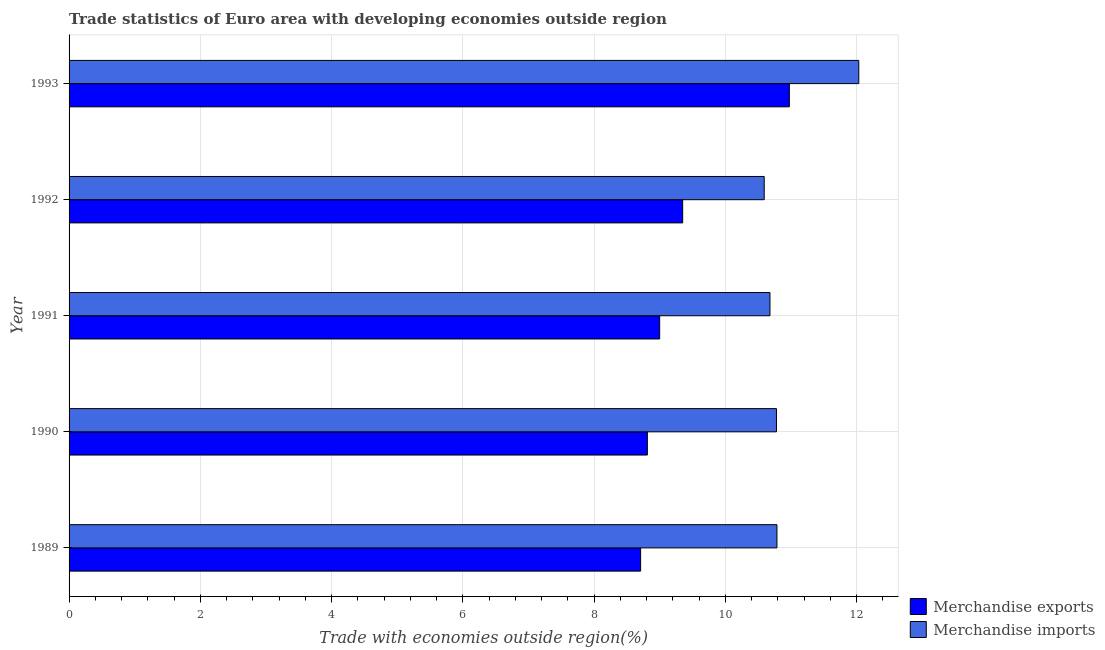How many different coloured bars are there?
Give a very brief answer. 2. Are the number of bars per tick equal to the number of legend labels?
Your answer should be very brief. Yes. Are the number of bars on each tick of the Y-axis equal?
Offer a terse response. Yes. How many bars are there on the 1st tick from the top?
Ensure brevity in your answer.  2. What is the label of the 4th group of bars from the top?
Offer a very short reply. 1990. In how many cases, is the number of bars for a given year not equal to the number of legend labels?
Your answer should be very brief. 0. What is the merchandise imports in 1992?
Offer a very short reply. 10.59. Across all years, what is the maximum merchandise exports?
Make the answer very short. 10.98. Across all years, what is the minimum merchandise imports?
Give a very brief answer. 10.59. In which year was the merchandise imports maximum?
Give a very brief answer. 1993. What is the total merchandise exports in the graph?
Your answer should be very brief. 46.85. What is the difference between the merchandise exports in 1989 and that in 1992?
Offer a terse response. -0.64. What is the difference between the merchandise imports in 1992 and the merchandise exports in 1989?
Give a very brief answer. 1.88. What is the average merchandise imports per year?
Keep it short and to the point. 10.97. In the year 1990, what is the difference between the merchandise imports and merchandise exports?
Ensure brevity in your answer.  1.97. In how many years, is the merchandise exports greater than 8.4 %?
Make the answer very short. 5. What is the ratio of the merchandise exports in 1991 to that in 1993?
Offer a very short reply. 0.82. Is the merchandise exports in 1990 less than that in 1993?
Your answer should be compact. Yes. What is the difference between the highest and the second highest merchandise exports?
Your answer should be very brief. 1.63. What is the difference between the highest and the lowest merchandise exports?
Ensure brevity in your answer.  2.27. In how many years, is the merchandise imports greater than the average merchandise imports taken over all years?
Ensure brevity in your answer.  1. Is the sum of the merchandise imports in 1991 and 1992 greater than the maximum merchandise exports across all years?
Your answer should be very brief. Yes. Are all the bars in the graph horizontal?
Your answer should be compact. Yes. How many years are there in the graph?
Make the answer very short. 5. Are the values on the major ticks of X-axis written in scientific E-notation?
Ensure brevity in your answer.  No. Does the graph contain any zero values?
Make the answer very short. No. Does the graph contain grids?
Your answer should be very brief. Yes. How many legend labels are there?
Ensure brevity in your answer.  2. What is the title of the graph?
Give a very brief answer. Trade statistics of Euro area with developing economies outside region. What is the label or title of the X-axis?
Offer a terse response. Trade with economies outside region(%). What is the Trade with economies outside region(%) in Merchandise exports in 1989?
Make the answer very short. 8.71. What is the Trade with economies outside region(%) of Merchandise imports in 1989?
Keep it short and to the point. 10.79. What is the Trade with economies outside region(%) of Merchandise exports in 1990?
Your answer should be compact. 8.81. What is the Trade with economies outside region(%) in Merchandise imports in 1990?
Offer a very short reply. 10.78. What is the Trade with economies outside region(%) in Merchandise exports in 1991?
Offer a very short reply. 9. What is the Trade with economies outside region(%) in Merchandise imports in 1991?
Make the answer very short. 10.68. What is the Trade with economies outside region(%) of Merchandise exports in 1992?
Make the answer very short. 9.35. What is the Trade with economies outside region(%) of Merchandise imports in 1992?
Give a very brief answer. 10.59. What is the Trade with economies outside region(%) in Merchandise exports in 1993?
Give a very brief answer. 10.98. What is the Trade with economies outside region(%) in Merchandise imports in 1993?
Your response must be concise. 12.03. Across all years, what is the maximum Trade with economies outside region(%) in Merchandise exports?
Provide a short and direct response. 10.98. Across all years, what is the maximum Trade with economies outside region(%) in Merchandise imports?
Offer a terse response. 12.03. Across all years, what is the minimum Trade with economies outside region(%) of Merchandise exports?
Your answer should be very brief. 8.71. Across all years, what is the minimum Trade with economies outside region(%) in Merchandise imports?
Provide a short and direct response. 10.59. What is the total Trade with economies outside region(%) of Merchandise exports in the graph?
Your answer should be compact. 46.85. What is the total Trade with economies outside region(%) in Merchandise imports in the graph?
Your answer should be compact. 54.88. What is the difference between the Trade with economies outside region(%) in Merchandise exports in 1989 and that in 1990?
Ensure brevity in your answer.  -0.1. What is the difference between the Trade with economies outside region(%) in Merchandise imports in 1989 and that in 1990?
Ensure brevity in your answer.  0.01. What is the difference between the Trade with economies outside region(%) of Merchandise exports in 1989 and that in 1991?
Give a very brief answer. -0.29. What is the difference between the Trade with economies outside region(%) in Merchandise imports in 1989 and that in 1991?
Ensure brevity in your answer.  0.11. What is the difference between the Trade with economies outside region(%) of Merchandise exports in 1989 and that in 1992?
Your answer should be compact. -0.64. What is the difference between the Trade with economies outside region(%) of Merchandise imports in 1989 and that in 1992?
Give a very brief answer. 0.19. What is the difference between the Trade with economies outside region(%) of Merchandise exports in 1989 and that in 1993?
Offer a very short reply. -2.27. What is the difference between the Trade with economies outside region(%) in Merchandise imports in 1989 and that in 1993?
Your answer should be compact. -1.25. What is the difference between the Trade with economies outside region(%) of Merchandise exports in 1990 and that in 1991?
Your response must be concise. -0.19. What is the difference between the Trade with economies outside region(%) of Merchandise imports in 1990 and that in 1991?
Provide a succinct answer. 0.1. What is the difference between the Trade with economies outside region(%) in Merchandise exports in 1990 and that in 1992?
Offer a terse response. -0.54. What is the difference between the Trade with economies outside region(%) of Merchandise imports in 1990 and that in 1992?
Your answer should be very brief. 0.19. What is the difference between the Trade with economies outside region(%) in Merchandise exports in 1990 and that in 1993?
Offer a very short reply. -2.16. What is the difference between the Trade with economies outside region(%) of Merchandise imports in 1990 and that in 1993?
Your answer should be compact. -1.25. What is the difference between the Trade with economies outside region(%) of Merchandise exports in 1991 and that in 1992?
Give a very brief answer. -0.35. What is the difference between the Trade with economies outside region(%) of Merchandise imports in 1991 and that in 1992?
Make the answer very short. 0.09. What is the difference between the Trade with economies outside region(%) of Merchandise exports in 1991 and that in 1993?
Give a very brief answer. -1.98. What is the difference between the Trade with economies outside region(%) of Merchandise imports in 1991 and that in 1993?
Make the answer very short. -1.35. What is the difference between the Trade with economies outside region(%) in Merchandise exports in 1992 and that in 1993?
Provide a succinct answer. -1.63. What is the difference between the Trade with economies outside region(%) in Merchandise imports in 1992 and that in 1993?
Make the answer very short. -1.44. What is the difference between the Trade with economies outside region(%) of Merchandise exports in 1989 and the Trade with economies outside region(%) of Merchandise imports in 1990?
Your answer should be very brief. -2.07. What is the difference between the Trade with economies outside region(%) in Merchandise exports in 1989 and the Trade with economies outside region(%) in Merchandise imports in 1991?
Ensure brevity in your answer.  -1.97. What is the difference between the Trade with economies outside region(%) of Merchandise exports in 1989 and the Trade with economies outside region(%) of Merchandise imports in 1992?
Provide a succinct answer. -1.88. What is the difference between the Trade with economies outside region(%) in Merchandise exports in 1989 and the Trade with economies outside region(%) in Merchandise imports in 1993?
Provide a succinct answer. -3.32. What is the difference between the Trade with economies outside region(%) in Merchandise exports in 1990 and the Trade with economies outside region(%) in Merchandise imports in 1991?
Provide a short and direct response. -1.87. What is the difference between the Trade with economies outside region(%) of Merchandise exports in 1990 and the Trade with economies outside region(%) of Merchandise imports in 1992?
Your answer should be very brief. -1.78. What is the difference between the Trade with economies outside region(%) of Merchandise exports in 1990 and the Trade with economies outside region(%) of Merchandise imports in 1993?
Your response must be concise. -3.22. What is the difference between the Trade with economies outside region(%) in Merchandise exports in 1991 and the Trade with economies outside region(%) in Merchandise imports in 1992?
Your response must be concise. -1.59. What is the difference between the Trade with economies outside region(%) of Merchandise exports in 1991 and the Trade with economies outside region(%) of Merchandise imports in 1993?
Your answer should be very brief. -3.03. What is the difference between the Trade with economies outside region(%) of Merchandise exports in 1992 and the Trade with economies outside region(%) of Merchandise imports in 1993?
Your answer should be very brief. -2.68. What is the average Trade with economies outside region(%) in Merchandise exports per year?
Offer a very short reply. 9.37. What is the average Trade with economies outside region(%) of Merchandise imports per year?
Give a very brief answer. 10.98. In the year 1989, what is the difference between the Trade with economies outside region(%) of Merchandise exports and Trade with economies outside region(%) of Merchandise imports?
Keep it short and to the point. -2.08. In the year 1990, what is the difference between the Trade with economies outside region(%) in Merchandise exports and Trade with economies outside region(%) in Merchandise imports?
Your response must be concise. -1.97. In the year 1991, what is the difference between the Trade with economies outside region(%) in Merchandise exports and Trade with economies outside region(%) in Merchandise imports?
Your response must be concise. -1.68. In the year 1992, what is the difference between the Trade with economies outside region(%) of Merchandise exports and Trade with economies outside region(%) of Merchandise imports?
Offer a terse response. -1.24. In the year 1993, what is the difference between the Trade with economies outside region(%) in Merchandise exports and Trade with economies outside region(%) in Merchandise imports?
Make the answer very short. -1.06. What is the ratio of the Trade with economies outside region(%) in Merchandise exports in 1989 to that in 1990?
Offer a very short reply. 0.99. What is the ratio of the Trade with economies outside region(%) of Merchandise exports in 1989 to that in 1991?
Keep it short and to the point. 0.97. What is the ratio of the Trade with economies outside region(%) in Merchandise imports in 1989 to that in 1991?
Provide a succinct answer. 1.01. What is the ratio of the Trade with economies outside region(%) in Merchandise exports in 1989 to that in 1992?
Provide a short and direct response. 0.93. What is the ratio of the Trade with economies outside region(%) of Merchandise imports in 1989 to that in 1992?
Your response must be concise. 1.02. What is the ratio of the Trade with economies outside region(%) of Merchandise exports in 1989 to that in 1993?
Ensure brevity in your answer.  0.79. What is the ratio of the Trade with economies outside region(%) in Merchandise imports in 1989 to that in 1993?
Provide a succinct answer. 0.9. What is the ratio of the Trade with economies outside region(%) in Merchandise exports in 1990 to that in 1991?
Provide a succinct answer. 0.98. What is the ratio of the Trade with economies outside region(%) in Merchandise imports in 1990 to that in 1991?
Provide a succinct answer. 1.01. What is the ratio of the Trade with economies outside region(%) in Merchandise exports in 1990 to that in 1992?
Provide a succinct answer. 0.94. What is the ratio of the Trade with economies outside region(%) in Merchandise imports in 1990 to that in 1992?
Offer a terse response. 1.02. What is the ratio of the Trade with economies outside region(%) in Merchandise exports in 1990 to that in 1993?
Give a very brief answer. 0.8. What is the ratio of the Trade with economies outside region(%) in Merchandise imports in 1990 to that in 1993?
Offer a terse response. 0.9. What is the ratio of the Trade with economies outside region(%) of Merchandise exports in 1991 to that in 1992?
Make the answer very short. 0.96. What is the ratio of the Trade with economies outside region(%) of Merchandise imports in 1991 to that in 1992?
Keep it short and to the point. 1.01. What is the ratio of the Trade with economies outside region(%) in Merchandise exports in 1991 to that in 1993?
Give a very brief answer. 0.82. What is the ratio of the Trade with economies outside region(%) in Merchandise imports in 1991 to that in 1993?
Your answer should be very brief. 0.89. What is the ratio of the Trade with economies outside region(%) of Merchandise exports in 1992 to that in 1993?
Provide a short and direct response. 0.85. What is the ratio of the Trade with economies outside region(%) in Merchandise imports in 1992 to that in 1993?
Offer a terse response. 0.88. What is the difference between the highest and the second highest Trade with economies outside region(%) in Merchandise exports?
Offer a terse response. 1.63. What is the difference between the highest and the second highest Trade with economies outside region(%) of Merchandise imports?
Make the answer very short. 1.25. What is the difference between the highest and the lowest Trade with economies outside region(%) of Merchandise exports?
Give a very brief answer. 2.27. What is the difference between the highest and the lowest Trade with economies outside region(%) of Merchandise imports?
Give a very brief answer. 1.44. 